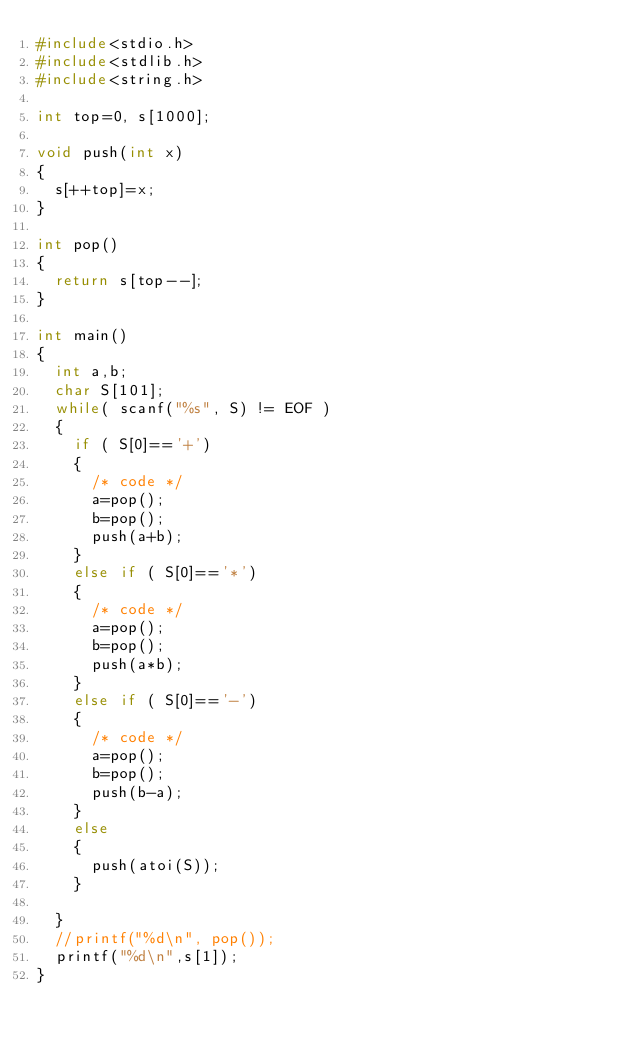Convert code to text. <code><loc_0><loc_0><loc_500><loc_500><_C_>#include<stdio.h>
#include<stdlib.h>
#include<string.h>

int top=0, s[1000];

void push(int x)
{
	s[++top]=x;
}

int pop()
{
	return s[top--];
}

int main()
{
	int a,b;
	char S[101];
	while( scanf("%s", S) != EOF )
	{
		if ( S[0]=='+')
		{
			/* code */
			a=pop();
			b=pop();
			push(a+b);			
		}
		else if ( S[0]=='*')
		{
			/* code */
			a=pop();
			b=pop();
			push(a*b);
		}
		else if ( S[0]=='-')
		{
			/* code */
			a=pop();
			b=pop();
			push(b-a);
		}
		else
		{
			push(atoi(S));
		}
		
	}
	//printf("%d\n", pop());
	printf("%d\n",s[1]);
}
</code> 